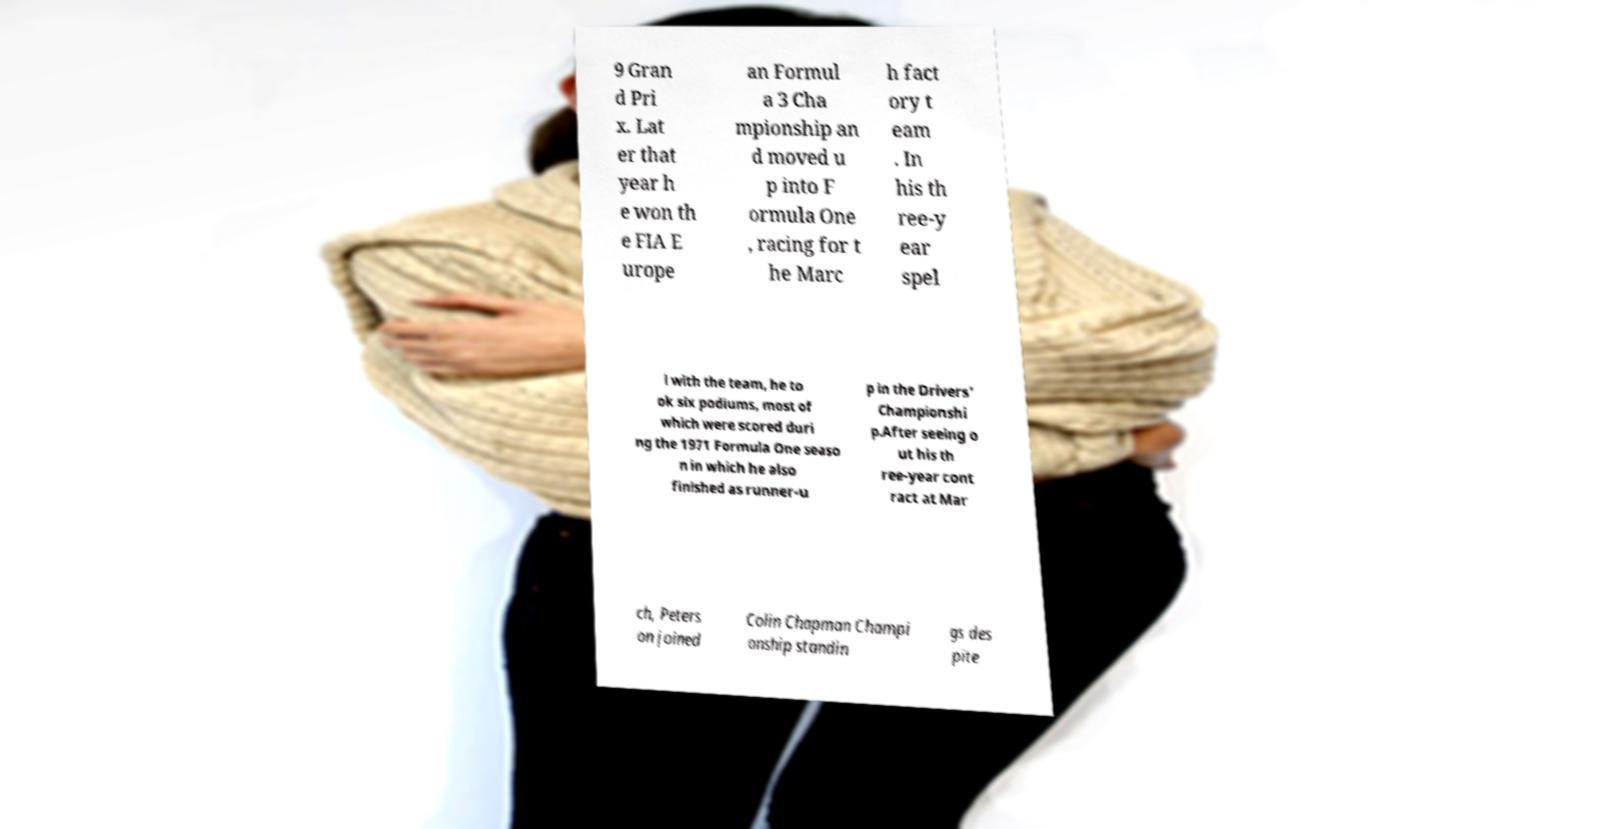Could you extract and type out the text from this image? 9 Gran d Pri x. Lat er that year h e won th e FIA E urope an Formul a 3 Cha mpionship an d moved u p into F ormula One , racing for t he Marc h fact ory t eam . In his th ree-y ear spel l with the team, he to ok six podiums, most of which were scored duri ng the 1971 Formula One seaso n in which he also finished as runner-u p in the Drivers' Championshi p.After seeing o ut his th ree-year cont ract at Mar ch, Peters on joined Colin Chapman Champi onship standin gs des pite 